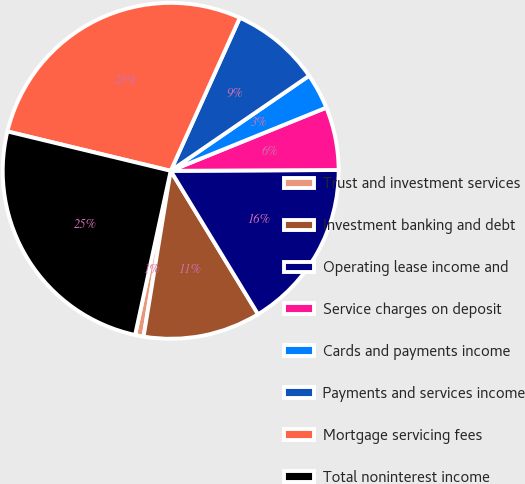Convert chart to OTSL. <chart><loc_0><loc_0><loc_500><loc_500><pie_chart><fcel>Trust and investment services<fcel>Investment banking and debt<fcel>Operating lease income and<fcel>Service charges on deposit<fcel>Cards and payments income<fcel>Payments and services income<fcel>Mortgage servicing fees<fcel>Total noninterest income<nl><fcel>0.82%<fcel>11.29%<fcel>16.37%<fcel>6.06%<fcel>3.44%<fcel>8.67%<fcel>27.99%<fcel>25.37%<nl></chart> 